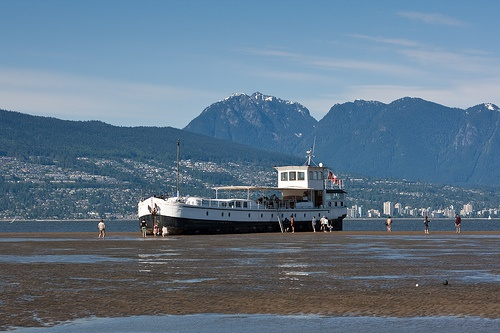Describe the objects in this image and their specific colors. I can see boat in gray, black, and white tones, people in gray, blue, and darkgray tones, people in gray, black, and tan tones, people in gray, black, and maroon tones, and people in gray, black, and blue tones in this image. 